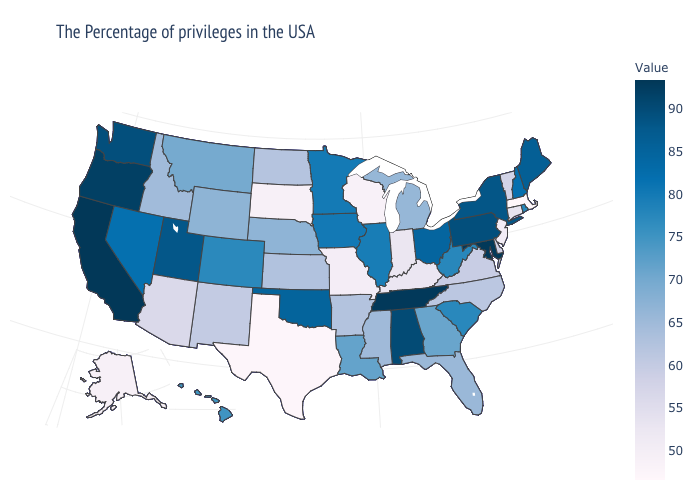Does Maryland have the lowest value in the South?
Short answer required. No. Which states have the lowest value in the USA?
Keep it brief. Massachusetts. Which states hav the highest value in the MidWest?
Give a very brief answer. Ohio. Does Montana have a higher value than New Hampshire?
Quick response, please. No. 